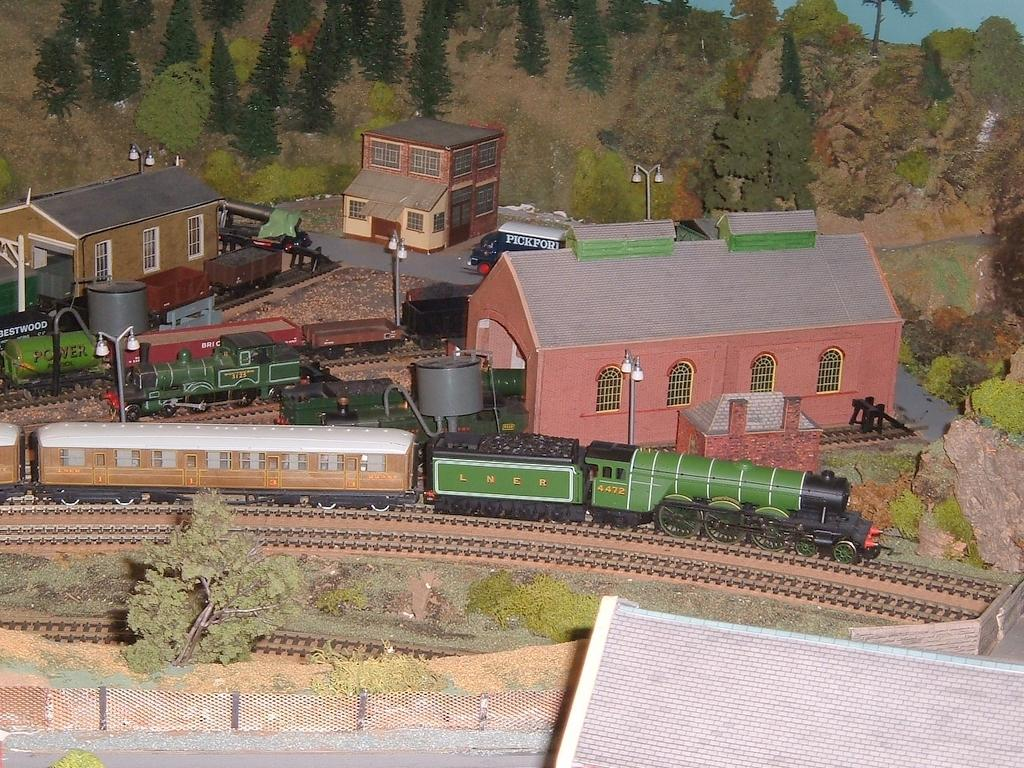What is the main subject in the center of the image? There are trains and houses in the center of the image. What type of vegetation can be seen at the top side of the image? There are trees at the top side of the image. What is present at the bottom side of the image? There is a boundary at the bottom side of the image. Where is the sofa located in the image? There is no sofa present in the image. What type of juice can be seen in the image? There is no juice present in the image. 